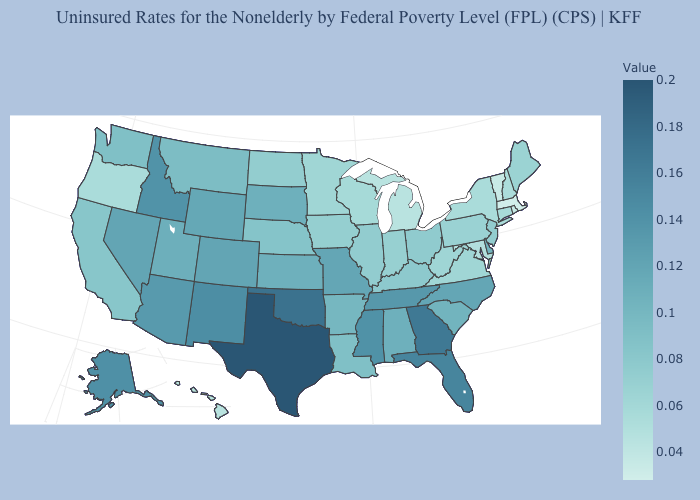Does Massachusetts have the lowest value in the USA?
Write a very short answer. Yes. Among the states that border Arkansas , does Mississippi have the lowest value?
Be succinct. No. Which states have the lowest value in the USA?
Answer briefly. Massachusetts. Does Indiana have a higher value than Tennessee?
Answer briefly. No. Does Massachusetts have the lowest value in the USA?
Answer briefly. Yes. 